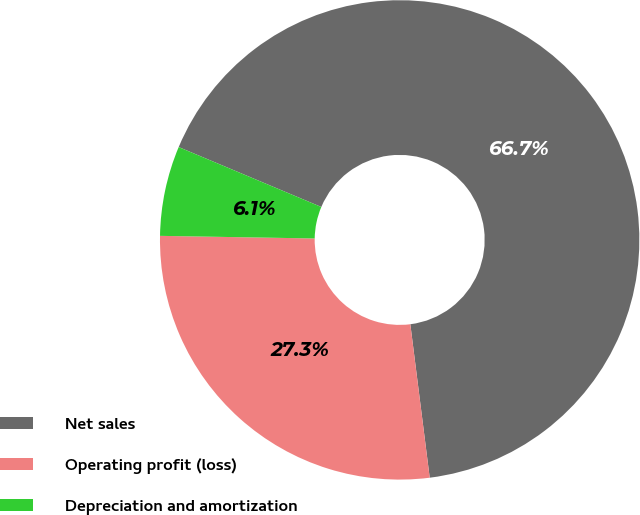Convert chart to OTSL. <chart><loc_0><loc_0><loc_500><loc_500><pie_chart><fcel>Net sales<fcel>Operating profit (loss)<fcel>Depreciation and amortization<nl><fcel>66.67%<fcel>27.27%<fcel>6.06%<nl></chart> 